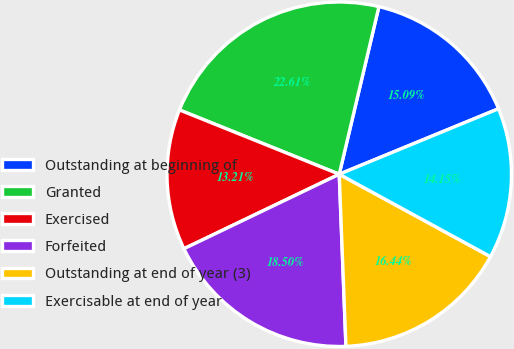Convert chart to OTSL. <chart><loc_0><loc_0><loc_500><loc_500><pie_chart><fcel>Outstanding at beginning of<fcel>Granted<fcel>Exercised<fcel>Forfeited<fcel>Outstanding at end of year (3)<fcel>Exercisable at end of year<nl><fcel>15.09%<fcel>22.61%<fcel>13.21%<fcel>18.5%<fcel>16.44%<fcel>14.15%<nl></chart> 